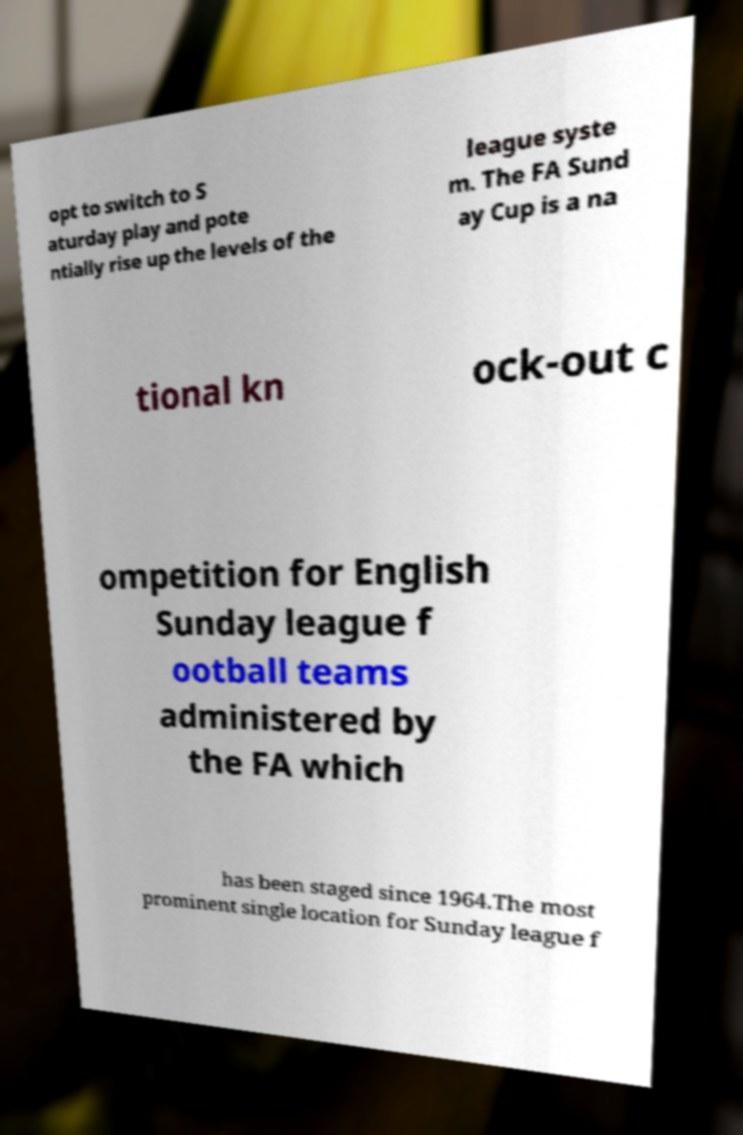I need the written content from this picture converted into text. Can you do that? opt to switch to S aturday play and pote ntially rise up the levels of the league syste m. The FA Sund ay Cup is a na tional kn ock-out c ompetition for English Sunday league f ootball teams administered by the FA which has been staged since 1964.The most prominent single location for Sunday league f 